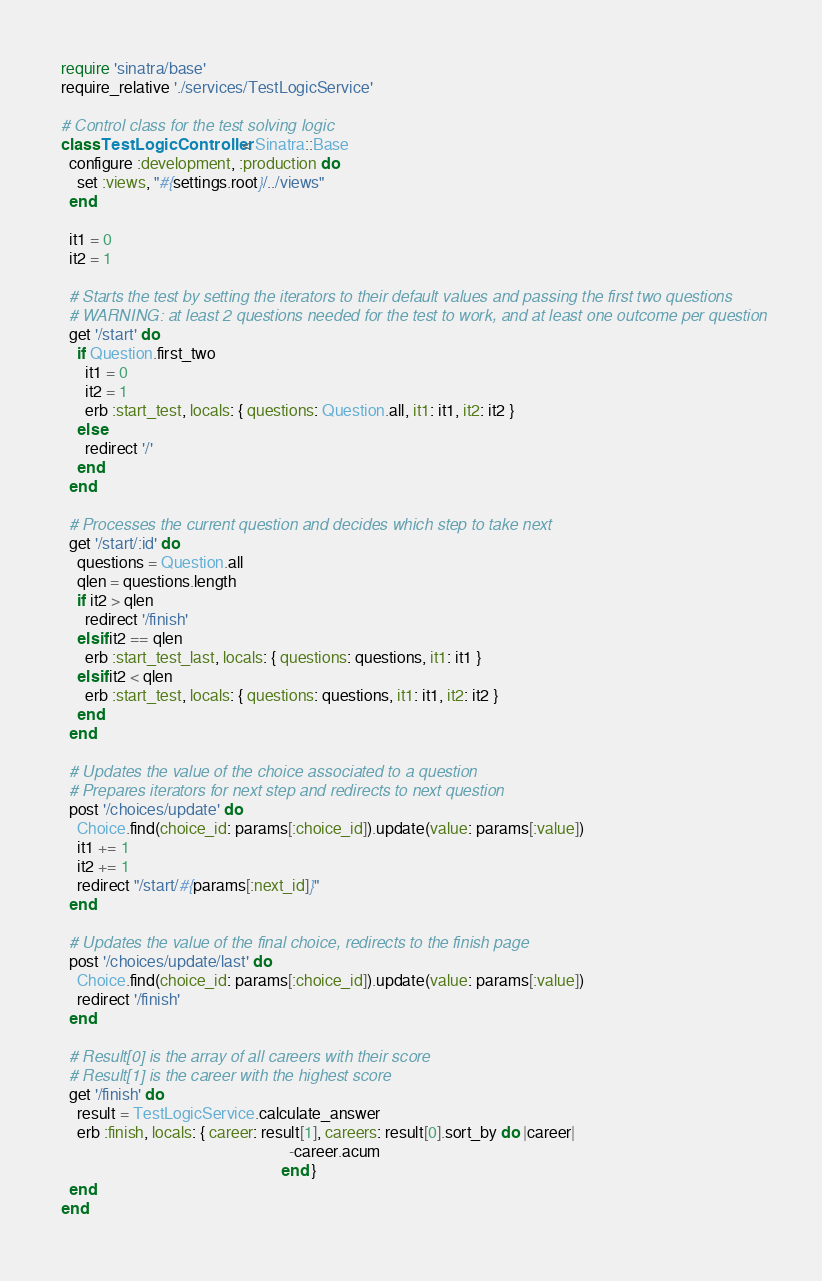Convert code to text. <code><loc_0><loc_0><loc_500><loc_500><_Ruby_>require 'sinatra/base'
require_relative './services/TestLogicService'

# Control class for the test solving logic
class TestLogicController < Sinatra::Base
  configure :development, :production do
    set :views, "#{settings.root}/../views"
  end

  it1 = 0
  it2 = 1

  # Starts the test by setting the iterators to their default values and passing the first two questions
  # WARNING: at least 2 questions needed for the test to work, and at least one outcome per question
  get '/start' do
    if Question.first_two
      it1 = 0
      it2 = 1
      erb :start_test, locals: { questions: Question.all, it1: it1, it2: it2 }
    else
      redirect '/'
    end
  end

  # Processes the current question and decides which step to take next
  get '/start/:id' do
    questions = Question.all
    qlen = questions.length
    if it2 > qlen
      redirect '/finish'
    elsif it2 == qlen
      erb :start_test_last, locals: { questions: questions, it1: it1 }
    elsif it2 < qlen
      erb :start_test, locals: { questions: questions, it1: it1, it2: it2 }
    end
  end

  # Updates the value of the choice associated to a question
  # Prepares iterators for next step and redirects to next question
  post '/choices/update' do
    Choice.find(choice_id: params[:choice_id]).update(value: params[:value])
    it1 += 1
    it2 += 1
    redirect "/start/#{params[:next_id]}"
  end

  # Updates the value of the final choice, redirects to the finish page
  post '/choices/update/last' do
    Choice.find(choice_id: params[:choice_id]).update(value: params[:value])
    redirect '/finish'
  end

  # Result[0] is the array of all careers with their score
  # Result[1] is the career with the highest score
  get '/finish' do
    result = TestLogicService.calculate_answer
    erb :finish, locals: { career: result[1], careers: result[0].sort_by do |career|
                                                         -career.acum
                                                       end }
  end
end
</code> 